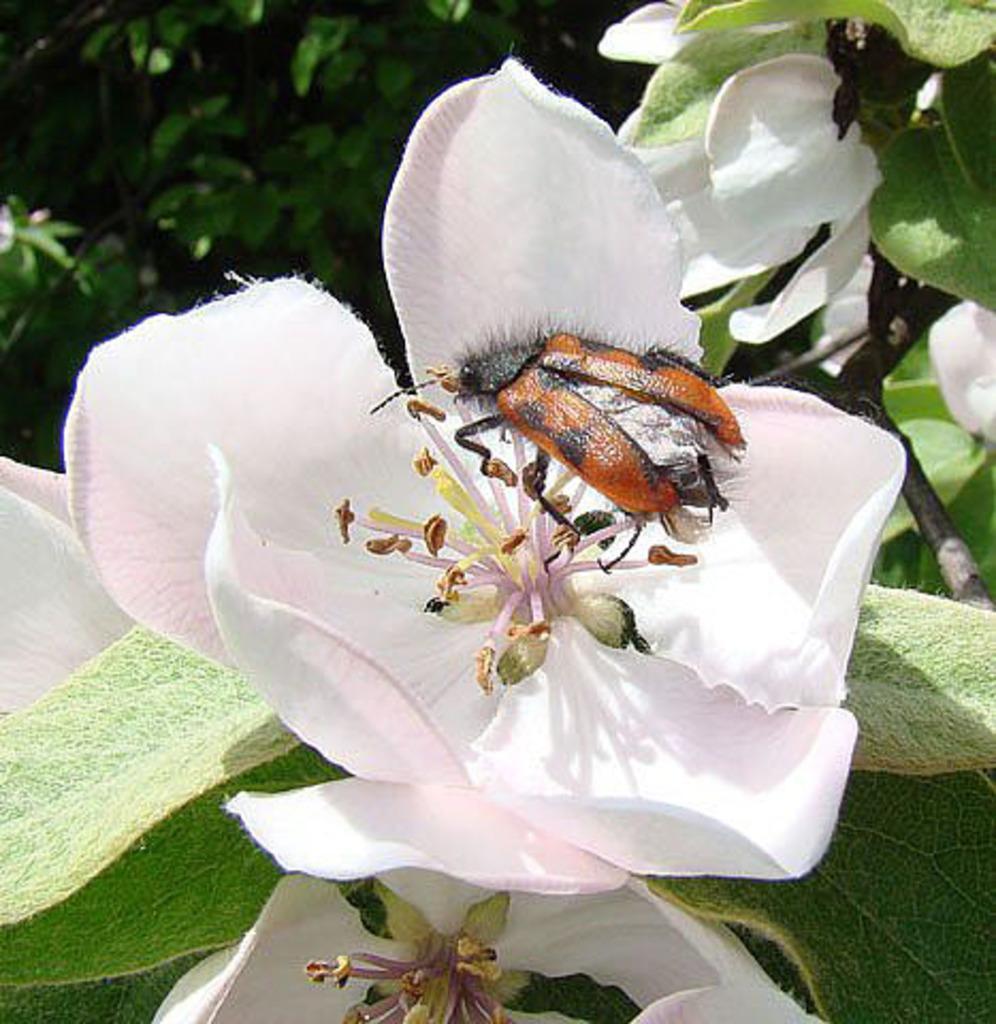Describe this image in one or two sentences. In this picture there is a flower in the center of the image, on which there is a bug and there are leaves and other flowers around the area of the image. 